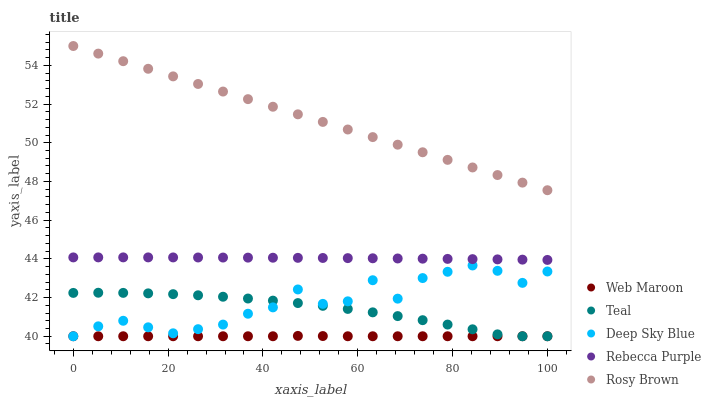Does Web Maroon have the minimum area under the curve?
Answer yes or no. Yes. Does Rosy Brown have the maximum area under the curve?
Answer yes or no. Yes. Does Deep Sky Blue have the minimum area under the curve?
Answer yes or no. No. Does Deep Sky Blue have the maximum area under the curve?
Answer yes or no. No. Is Rosy Brown the smoothest?
Answer yes or no. Yes. Is Deep Sky Blue the roughest?
Answer yes or no. Yes. Is Web Maroon the smoothest?
Answer yes or no. No. Is Web Maroon the roughest?
Answer yes or no. No. Does Web Maroon have the lowest value?
Answer yes or no. Yes. Does Rebecca Purple have the lowest value?
Answer yes or no. No. Does Rosy Brown have the highest value?
Answer yes or no. Yes. Does Deep Sky Blue have the highest value?
Answer yes or no. No. Is Teal less than Rebecca Purple?
Answer yes or no. Yes. Is Rebecca Purple greater than Web Maroon?
Answer yes or no. Yes. Does Web Maroon intersect Deep Sky Blue?
Answer yes or no. Yes. Is Web Maroon less than Deep Sky Blue?
Answer yes or no. No. Is Web Maroon greater than Deep Sky Blue?
Answer yes or no. No. Does Teal intersect Rebecca Purple?
Answer yes or no. No. 